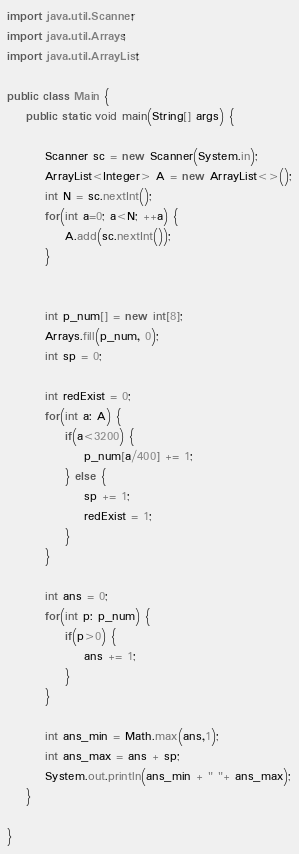<code> <loc_0><loc_0><loc_500><loc_500><_Java_>import java.util.Scanner;
import java.util.Arrays;
import java.util.ArrayList;

public class Main {
	public static void main(String[] args) {
		
		Scanner sc = new Scanner(System.in);
		ArrayList<Integer> A = new ArrayList<>();
		int N = sc.nextInt();
		for(int a=0; a<N; ++a) {
			A.add(sc.nextInt());
		}
		
		
		int p_num[] = new int[8];
		Arrays.fill(p_num, 0);
		int sp = 0;
		
		int redExist = 0;
		for(int a: A) {
			if(a<3200) {
				p_num[a/400] += 1;
			} else {
				sp += 1;
				redExist = 1;
			}
		}
		
		int ans = 0;
		for(int p: p_num) {
			if(p>0) {
				ans += 1;
			}
		}
		
		int ans_min = Math.max(ans,1);
		int ans_max = ans + sp;
		System.out.println(ans_min + " "+ ans_max);
	}

}
</code> 